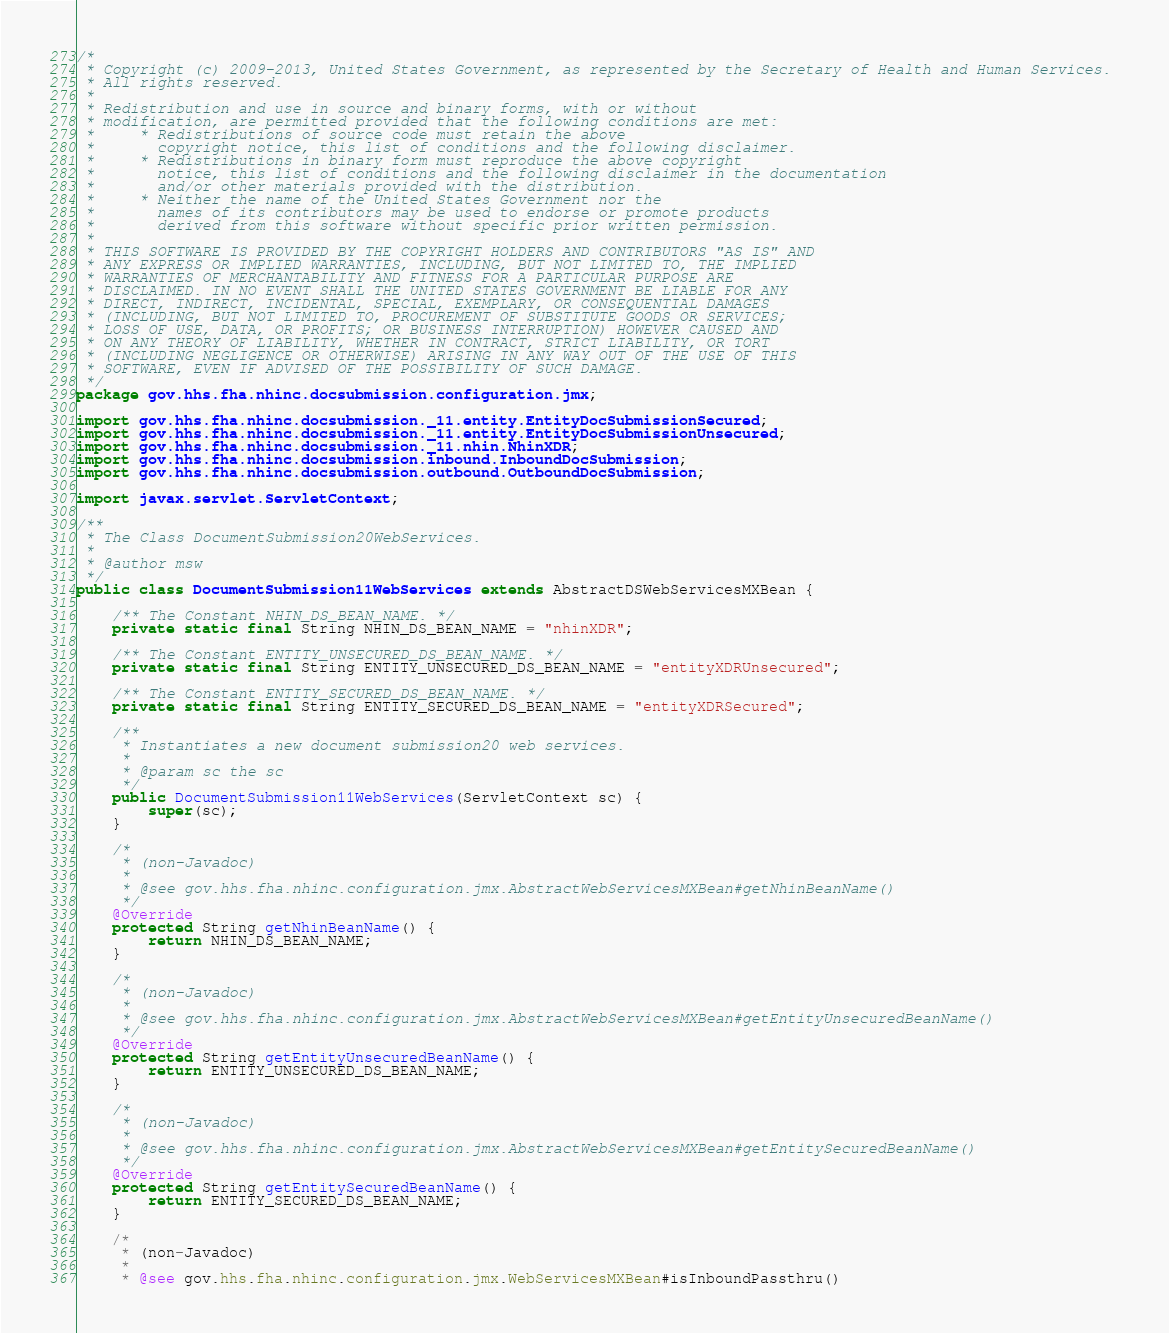<code> <loc_0><loc_0><loc_500><loc_500><_Java_>/*
 * Copyright (c) 2009-2013, United States Government, as represented by the Secretary of Health and Human Services. 
 * All rights reserved. 
 *
 * Redistribution and use in source and binary forms, with or without 
 * modification, are permitted provided that the following conditions are met: 
 *     * Redistributions of source code must retain the above 
 *       copyright notice, this list of conditions and the following disclaimer. 
 *     * Redistributions in binary form must reproduce the above copyright 
 *       notice, this list of conditions and the following disclaimer in the documentation 
 *       and/or other materials provided with the distribution. 
 *     * Neither the name of the United States Government nor the 
 *       names of its contributors may be used to endorse or promote products 
 *       derived from this software without specific prior written permission. 
 *
 * THIS SOFTWARE IS PROVIDED BY THE COPYRIGHT HOLDERS AND CONTRIBUTORS "AS IS" AND 
 * ANY EXPRESS OR IMPLIED WARRANTIES, INCLUDING, BUT NOT LIMITED TO, THE IMPLIED 
 * WARRANTIES OF MERCHANTABILITY AND FITNESS FOR A PARTICULAR PURPOSE ARE 
 * DISCLAIMED. IN NO EVENT SHALL THE UNITED STATES GOVERNMENT BE LIABLE FOR ANY 
 * DIRECT, INDIRECT, INCIDENTAL, SPECIAL, EXEMPLARY, OR CONSEQUENTIAL DAMAGES 
 * (INCLUDING, BUT NOT LIMITED TO, PROCUREMENT OF SUBSTITUTE GOODS OR SERVICES; 
 * LOSS OF USE, DATA, OR PROFITS; OR BUSINESS INTERRUPTION) HOWEVER CAUSED AND 
 * ON ANY THEORY OF LIABILITY, WHETHER IN CONTRACT, STRICT LIABILITY, OR TORT 
 * (INCLUDING NEGLIGENCE OR OTHERWISE) ARISING IN ANY WAY OUT OF THE USE OF THIS 
 * SOFTWARE, EVEN IF ADVISED OF THE POSSIBILITY OF SUCH DAMAGE. 
 */
package gov.hhs.fha.nhinc.docsubmission.configuration.jmx;

import gov.hhs.fha.nhinc.docsubmission._11.entity.EntityDocSubmissionSecured;
import gov.hhs.fha.nhinc.docsubmission._11.entity.EntityDocSubmissionUnsecured;
import gov.hhs.fha.nhinc.docsubmission._11.nhin.NhinXDR;
import gov.hhs.fha.nhinc.docsubmission.inbound.InboundDocSubmission;
import gov.hhs.fha.nhinc.docsubmission.outbound.OutboundDocSubmission;

import javax.servlet.ServletContext;

/**
 * The Class DocumentSubmission20WebServices.
 * 
 * @author msw
 */
public class DocumentSubmission11WebServices extends AbstractDSWebServicesMXBean {

    /** The Constant NHIN_DS_BEAN_NAME. */
    private static final String NHIN_DS_BEAN_NAME = "nhinXDR";

    /** The Constant ENTITY_UNSECURED_DS_BEAN_NAME. */
    private static final String ENTITY_UNSECURED_DS_BEAN_NAME = "entityXDRUnsecured";

    /** The Constant ENTITY_SECURED_DS_BEAN_NAME. */
    private static final String ENTITY_SECURED_DS_BEAN_NAME = "entityXDRSecured";
    
    /**
     * Instantiates a new document submission20 web services.
     * 
     * @param sc the sc
     */
    public DocumentSubmission11WebServices(ServletContext sc) {
        super(sc);
    }

    /*
     * (non-Javadoc)
     * 
     * @see gov.hhs.fha.nhinc.configuration.jmx.AbstractWebServicesMXBean#getNhinBeanName()
     */
    @Override
    protected String getNhinBeanName() {
        return NHIN_DS_BEAN_NAME;
    }

    /*
     * (non-Javadoc)
     * 
     * @see gov.hhs.fha.nhinc.configuration.jmx.AbstractWebServicesMXBean#getEntityUnsecuredBeanName()
     */
    @Override
    protected String getEntityUnsecuredBeanName() {
        return ENTITY_UNSECURED_DS_BEAN_NAME;
    }

    /*
     * (non-Javadoc)
     * 
     * @see gov.hhs.fha.nhinc.configuration.jmx.AbstractWebServicesMXBean#getEntitySecuredBeanName()
     */
    @Override
    protected String getEntitySecuredBeanName() {
        return ENTITY_SECURED_DS_BEAN_NAME;
    }
    
    /*
     * (non-Javadoc)
     * 
     * @see gov.hhs.fha.nhinc.configuration.jmx.WebServicesMXBean#isInboundPassthru()</code> 